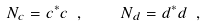Convert formula to latex. <formula><loc_0><loc_0><loc_500><loc_500>N _ { c } = c ^ { * } c \ , \quad N _ { d } = d ^ { * } d \ ,</formula> 